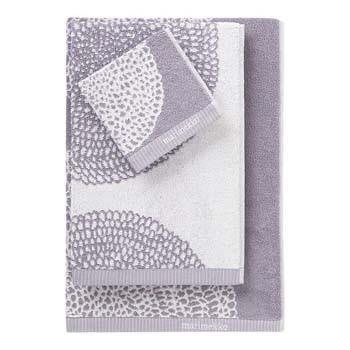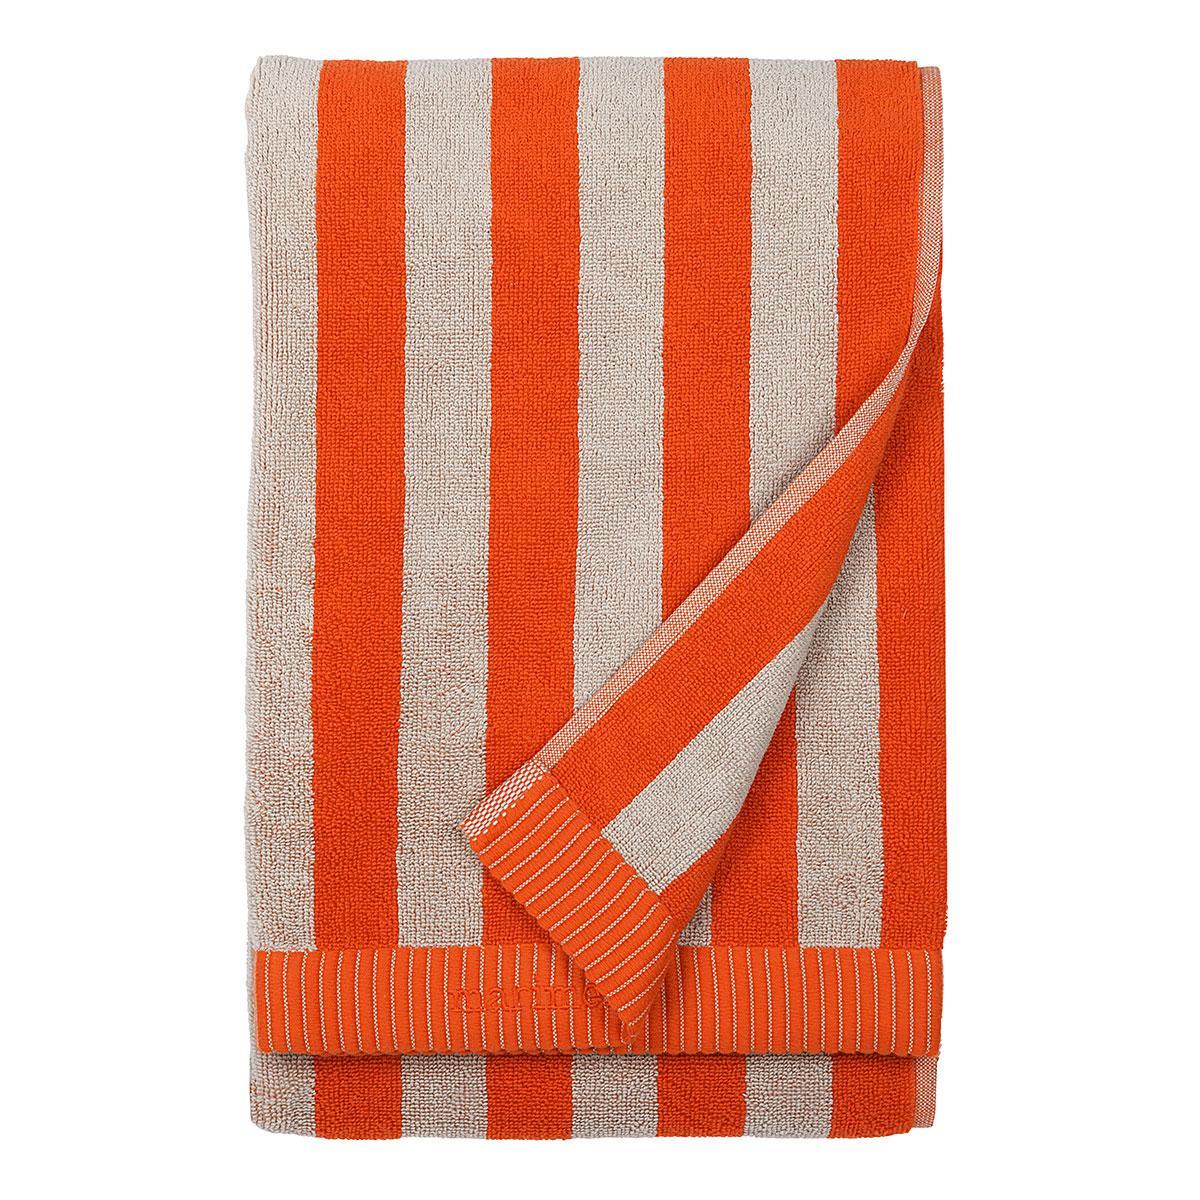The first image is the image on the left, the second image is the image on the right. Evaluate the accuracy of this statement regarding the images: "Exactly one towel's bottom right corner is folded over.". Is it true? Answer yes or no. Yes. 